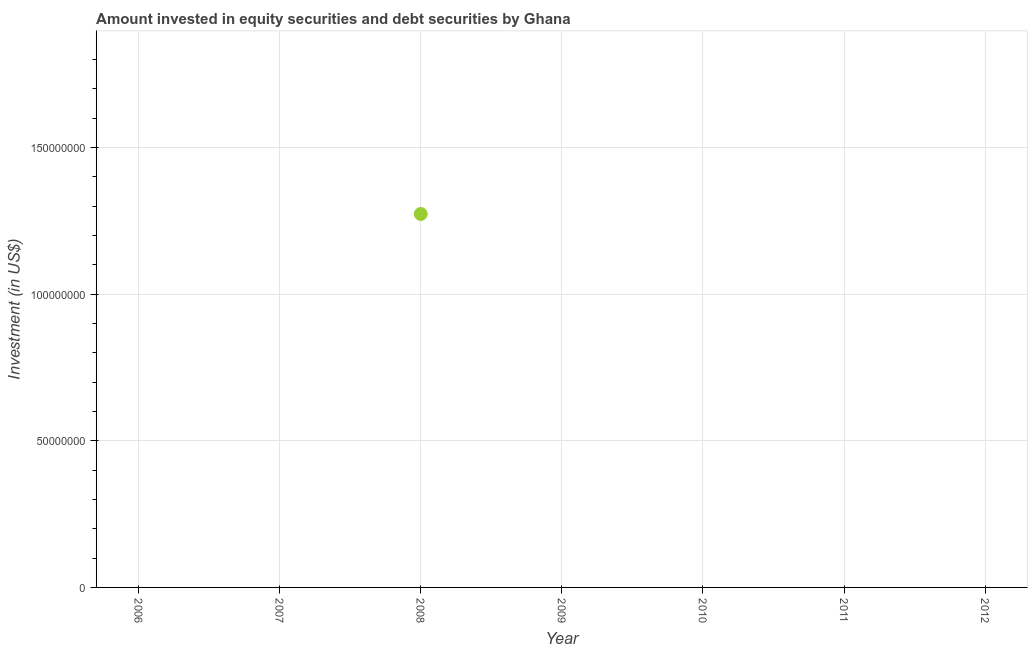What is the portfolio investment in 2012?
Ensure brevity in your answer.  0. Across all years, what is the maximum portfolio investment?
Keep it short and to the point. 1.27e+08. Across all years, what is the minimum portfolio investment?
Ensure brevity in your answer.  0. In which year was the portfolio investment maximum?
Ensure brevity in your answer.  2008. What is the sum of the portfolio investment?
Make the answer very short. 1.27e+08. What is the average portfolio investment per year?
Provide a short and direct response. 1.82e+07. What is the difference between the highest and the lowest portfolio investment?
Provide a succinct answer. 1.27e+08. Does the portfolio investment monotonically increase over the years?
Your response must be concise. No. How many dotlines are there?
Offer a terse response. 1. How many years are there in the graph?
Provide a succinct answer. 7. What is the difference between two consecutive major ticks on the Y-axis?
Your response must be concise. 5.00e+07. Does the graph contain any zero values?
Make the answer very short. Yes. What is the title of the graph?
Ensure brevity in your answer.  Amount invested in equity securities and debt securities by Ghana. What is the label or title of the X-axis?
Your response must be concise. Year. What is the label or title of the Y-axis?
Your answer should be very brief. Investment (in US$). What is the Investment (in US$) in 2008?
Your answer should be compact. 1.27e+08. What is the Investment (in US$) in 2009?
Your answer should be compact. 0. What is the Investment (in US$) in 2012?
Provide a succinct answer. 0. 